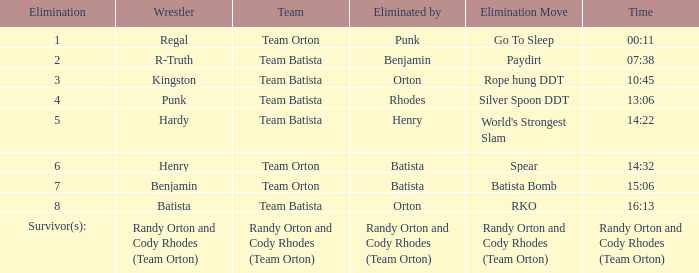Which elimination action is noted against team orton, eliminated by batista during elimination number 7? Batista Bomb. 